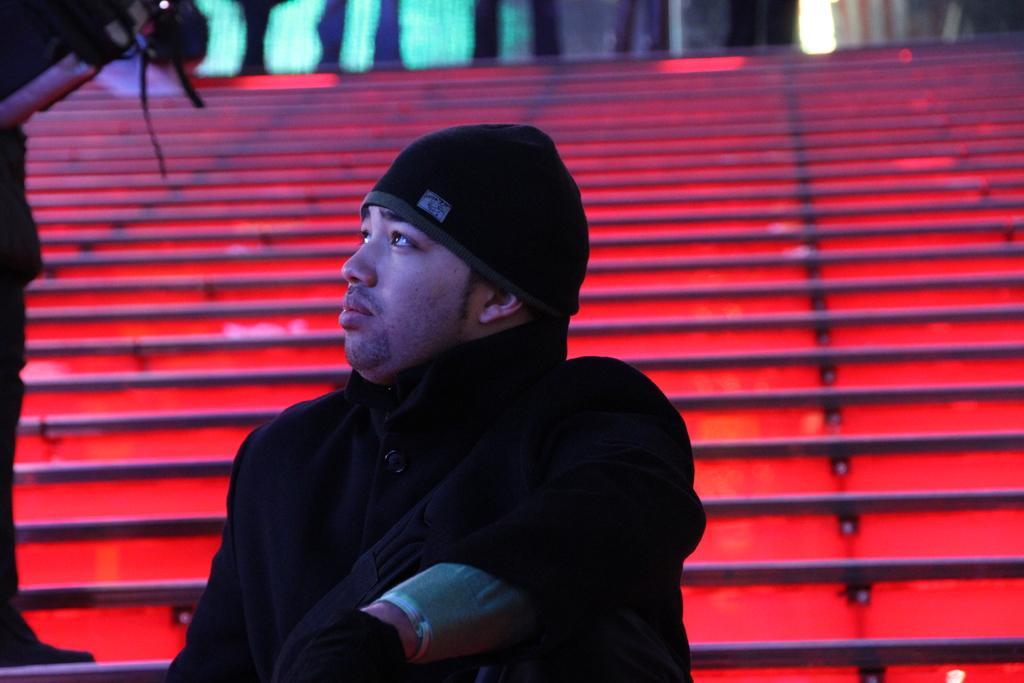Describe this image in one or two sentences. As we can see in the image there are stairs and two people. The man over here is wearing black color dress. 